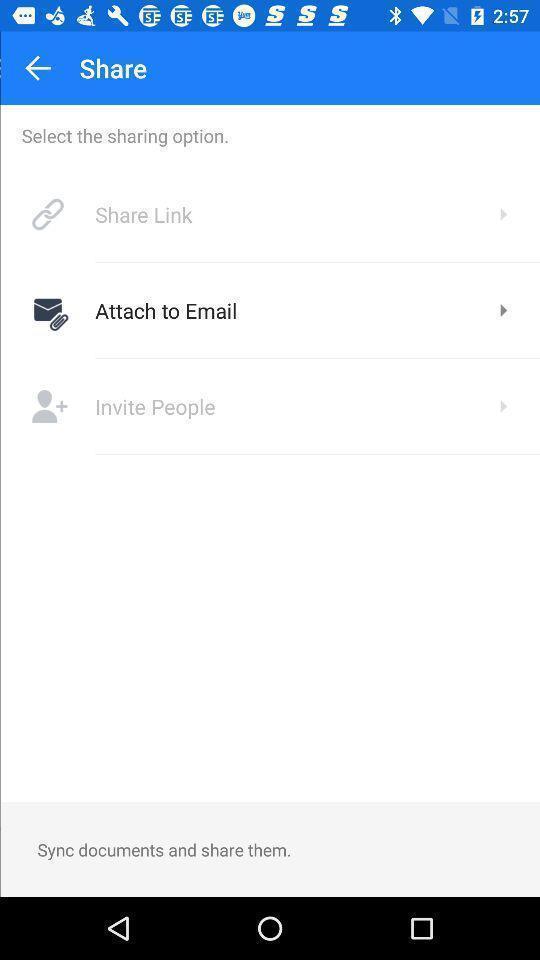What is the overall content of this screenshot? Screen shows share option. 